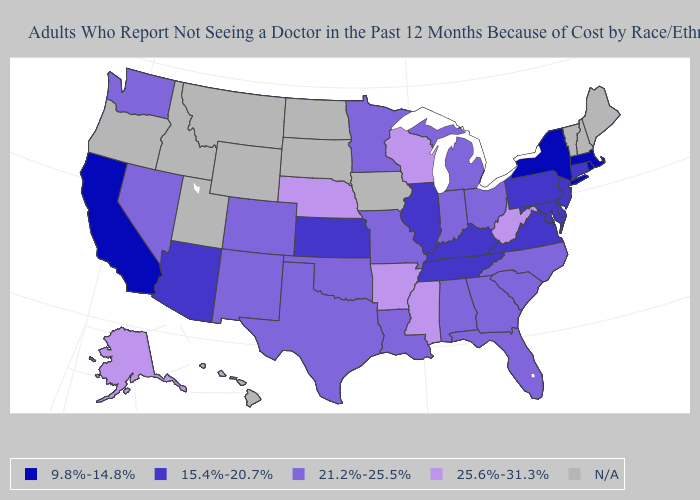What is the value of North Carolina?
Concise answer only. 21.2%-25.5%. What is the highest value in the West ?
Concise answer only. 25.6%-31.3%. Name the states that have a value in the range 9.8%-14.8%?
Be succinct. California, Massachusetts, New York, Rhode Island. What is the highest value in the USA?
Give a very brief answer. 25.6%-31.3%. Name the states that have a value in the range 21.2%-25.5%?
Quick response, please. Alabama, Colorado, Florida, Georgia, Indiana, Louisiana, Michigan, Minnesota, Missouri, Nevada, New Mexico, North Carolina, Ohio, Oklahoma, South Carolina, Texas, Washington. Name the states that have a value in the range 15.4%-20.7%?
Give a very brief answer. Arizona, Connecticut, Delaware, Illinois, Kansas, Kentucky, Maryland, New Jersey, Pennsylvania, Tennessee, Virginia. Name the states that have a value in the range 21.2%-25.5%?
Short answer required. Alabama, Colorado, Florida, Georgia, Indiana, Louisiana, Michigan, Minnesota, Missouri, Nevada, New Mexico, North Carolina, Ohio, Oklahoma, South Carolina, Texas, Washington. Among the states that border Rhode Island , which have the highest value?
Write a very short answer. Connecticut. Does North Carolina have the highest value in the South?
Give a very brief answer. No. What is the lowest value in the USA?
Answer briefly. 9.8%-14.8%. Name the states that have a value in the range 25.6%-31.3%?
Give a very brief answer. Alaska, Arkansas, Mississippi, Nebraska, West Virginia, Wisconsin. What is the value of Alaska?
Quick response, please. 25.6%-31.3%. Does Alaska have the lowest value in the West?
Concise answer only. No. What is the highest value in states that border Florida?
Quick response, please. 21.2%-25.5%. 